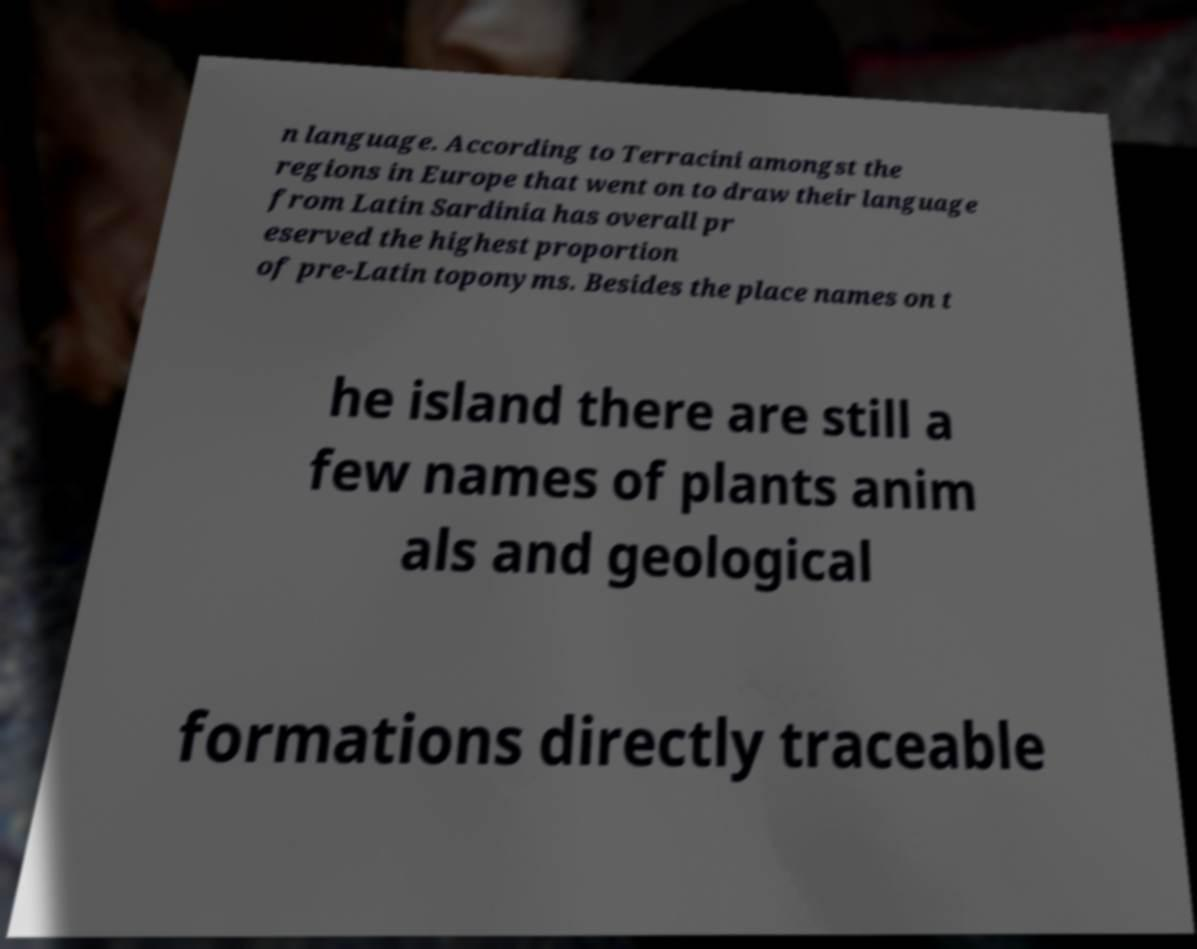Please identify and transcribe the text found in this image. n language. According to Terracini amongst the regions in Europe that went on to draw their language from Latin Sardinia has overall pr eserved the highest proportion of pre-Latin toponyms. Besides the place names on t he island there are still a few names of plants anim als and geological formations directly traceable 